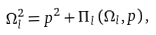Convert formula to latex. <formula><loc_0><loc_0><loc_500><loc_500>\Omega _ { l } ^ { 2 } = p ^ { 2 } + \Pi _ { l } \left ( \Omega _ { l } , p \right ) ,</formula> 